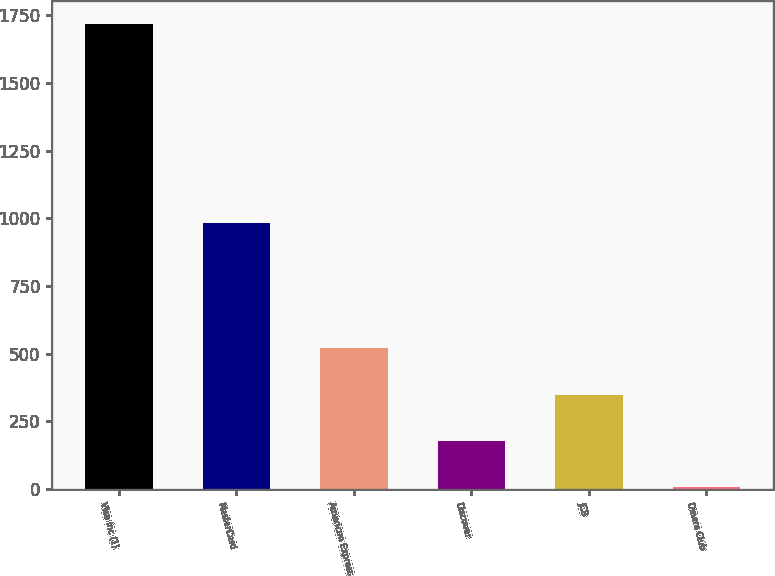Convert chart to OTSL. <chart><loc_0><loc_0><loc_500><loc_500><bar_chart><fcel>Visa Inc (1)<fcel>MasterCard<fcel>American Express<fcel>Discover<fcel>JCB<fcel>Diners Club<nl><fcel>1717<fcel>981<fcel>520<fcel>178<fcel>349<fcel>7<nl></chart> 